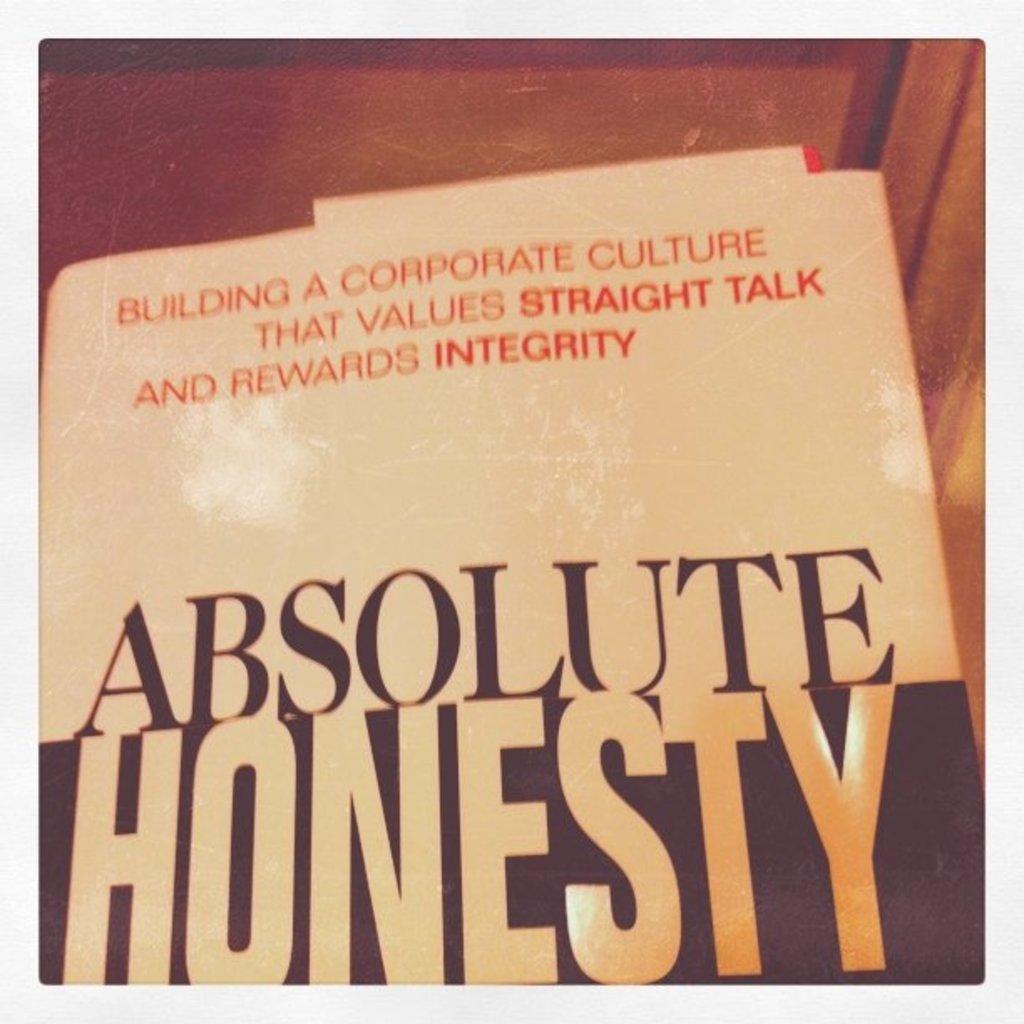What are the three bold words?
Provide a short and direct response. Straight talk integrity. 